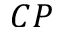<formula> <loc_0><loc_0><loc_500><loc_500>{ C P }</formula> 